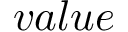Convert formula to latex. <formula><loc_0><loc_0><loc_500><loc_500>v a l u e</formula> 